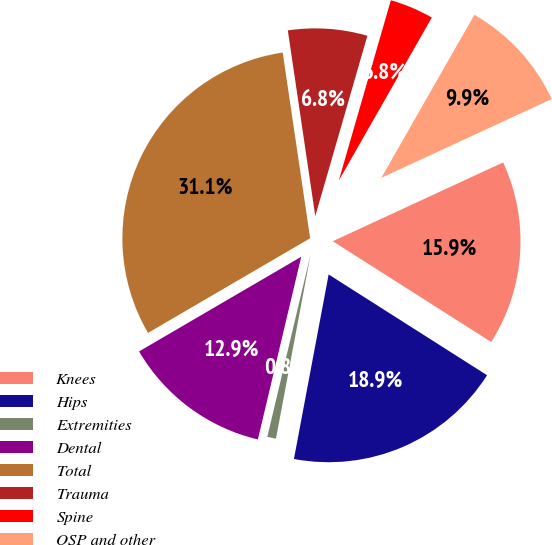<chart> <loc_0><loc_0><loc_500><loc_500><pie_chart><fcel>Knees<fcel>Hips<fcel>Extremities<fcel>Dental<fcel>Total<fcel>Trauma<fcel>Spine<fcel>OSP and other<nl><fcel>15.91%<fcel>18.94%<fcel>0.75%<fcel>12.88%<fcel>31.07%<fcel>6.81%<fcel>3.78%<fcel>9.85%<nl></chart> 